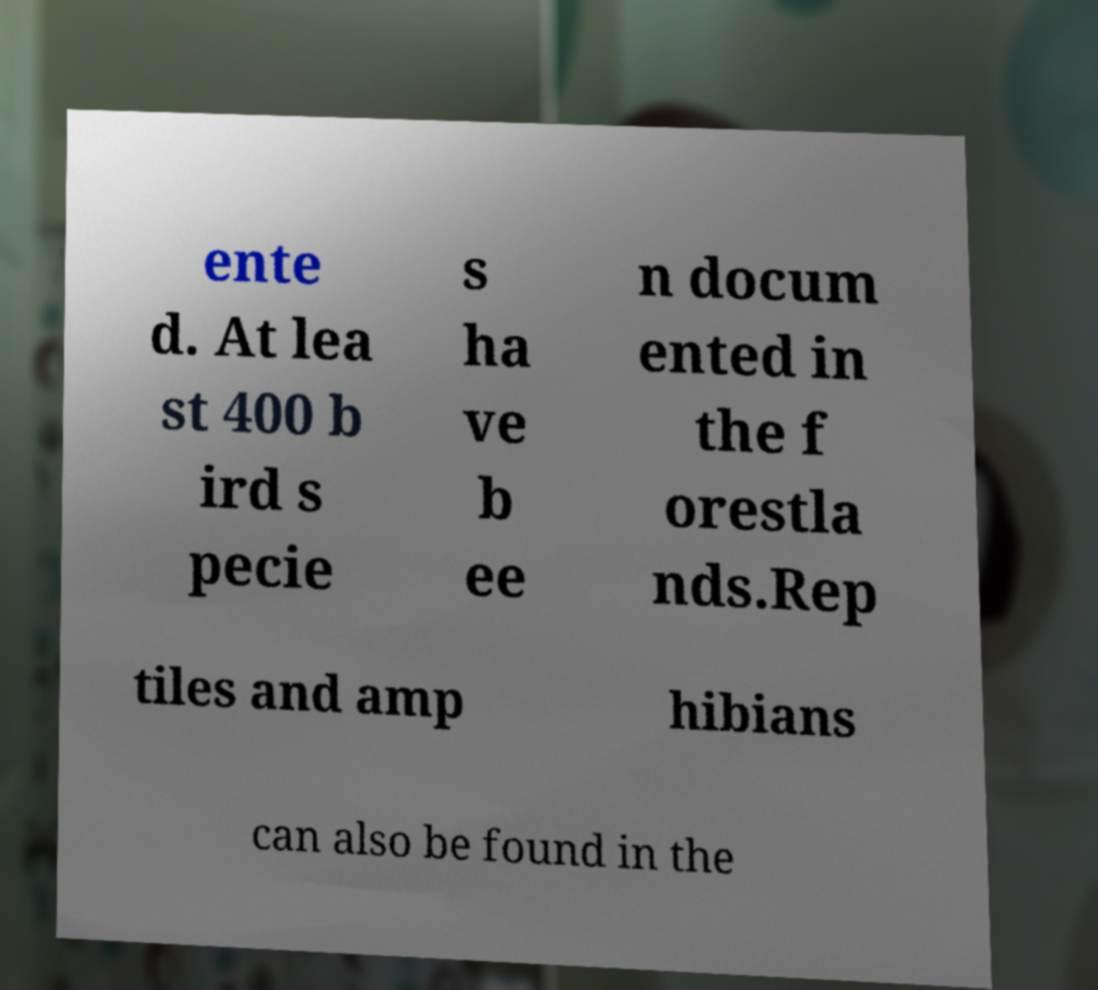For documentation purposes, I need the text within this image transcribed. Could you provide that? ente d. At lea st 400 b ird s pecie s ha ve b ee n docum ented in the f orestla nds.Rep tiles and amp hibians can also be found in the 